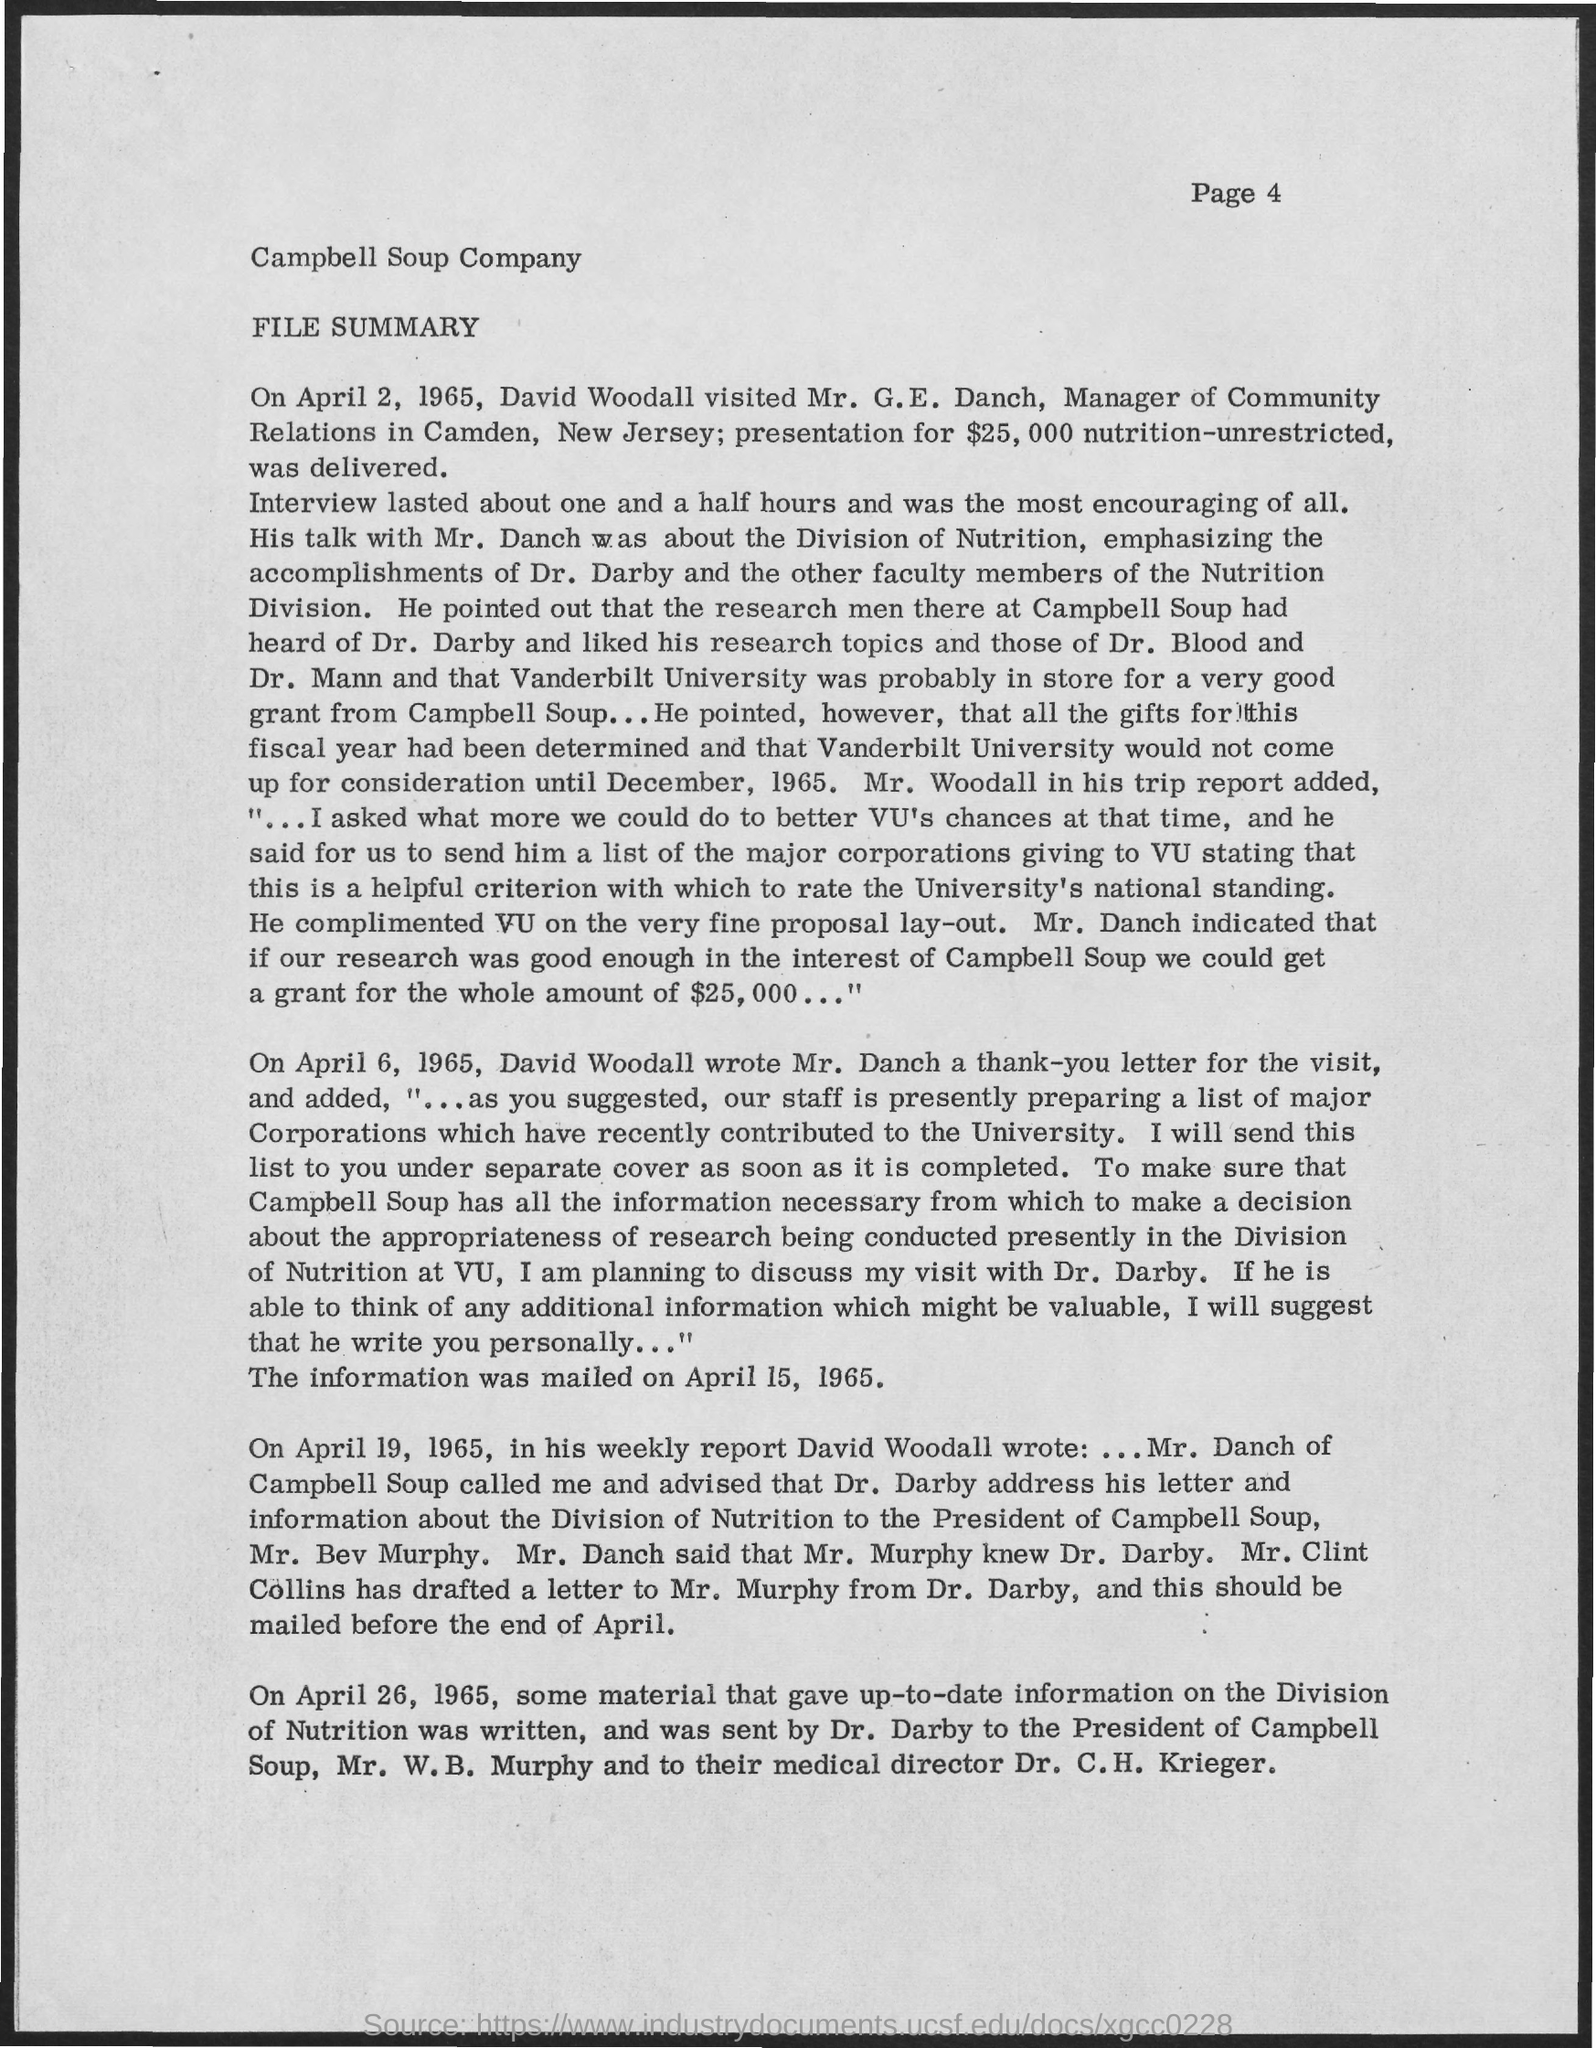What is the Company Name ?
Provide a succinct answer. Campbell Soup  Company. 